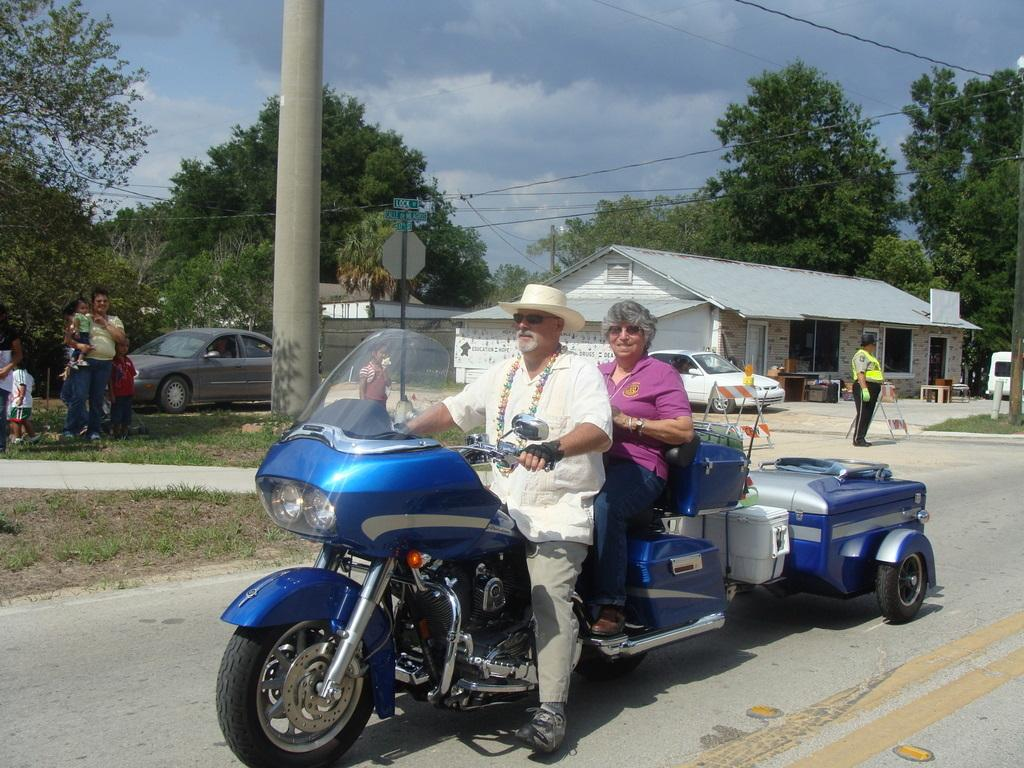What is the person in the image wearing on their head? The person in the image is wearing a hat. What is the person doing in the image? The person is sitting on a bike. Can you describe the person's surroundings in the image? There are trees, buildings, and a car in the background of the image. Is there anyone else visible in the image? Yes, there is a woman behind the person on the bike. What type of chicken can be seen riding the bike with the person in the image? There is no chicken present in the image; it features a person sitting on a bike with a woman behind them. What is the weight of the plough visible in the image? There is no plough present in the image, so its weight cannot be determined. 